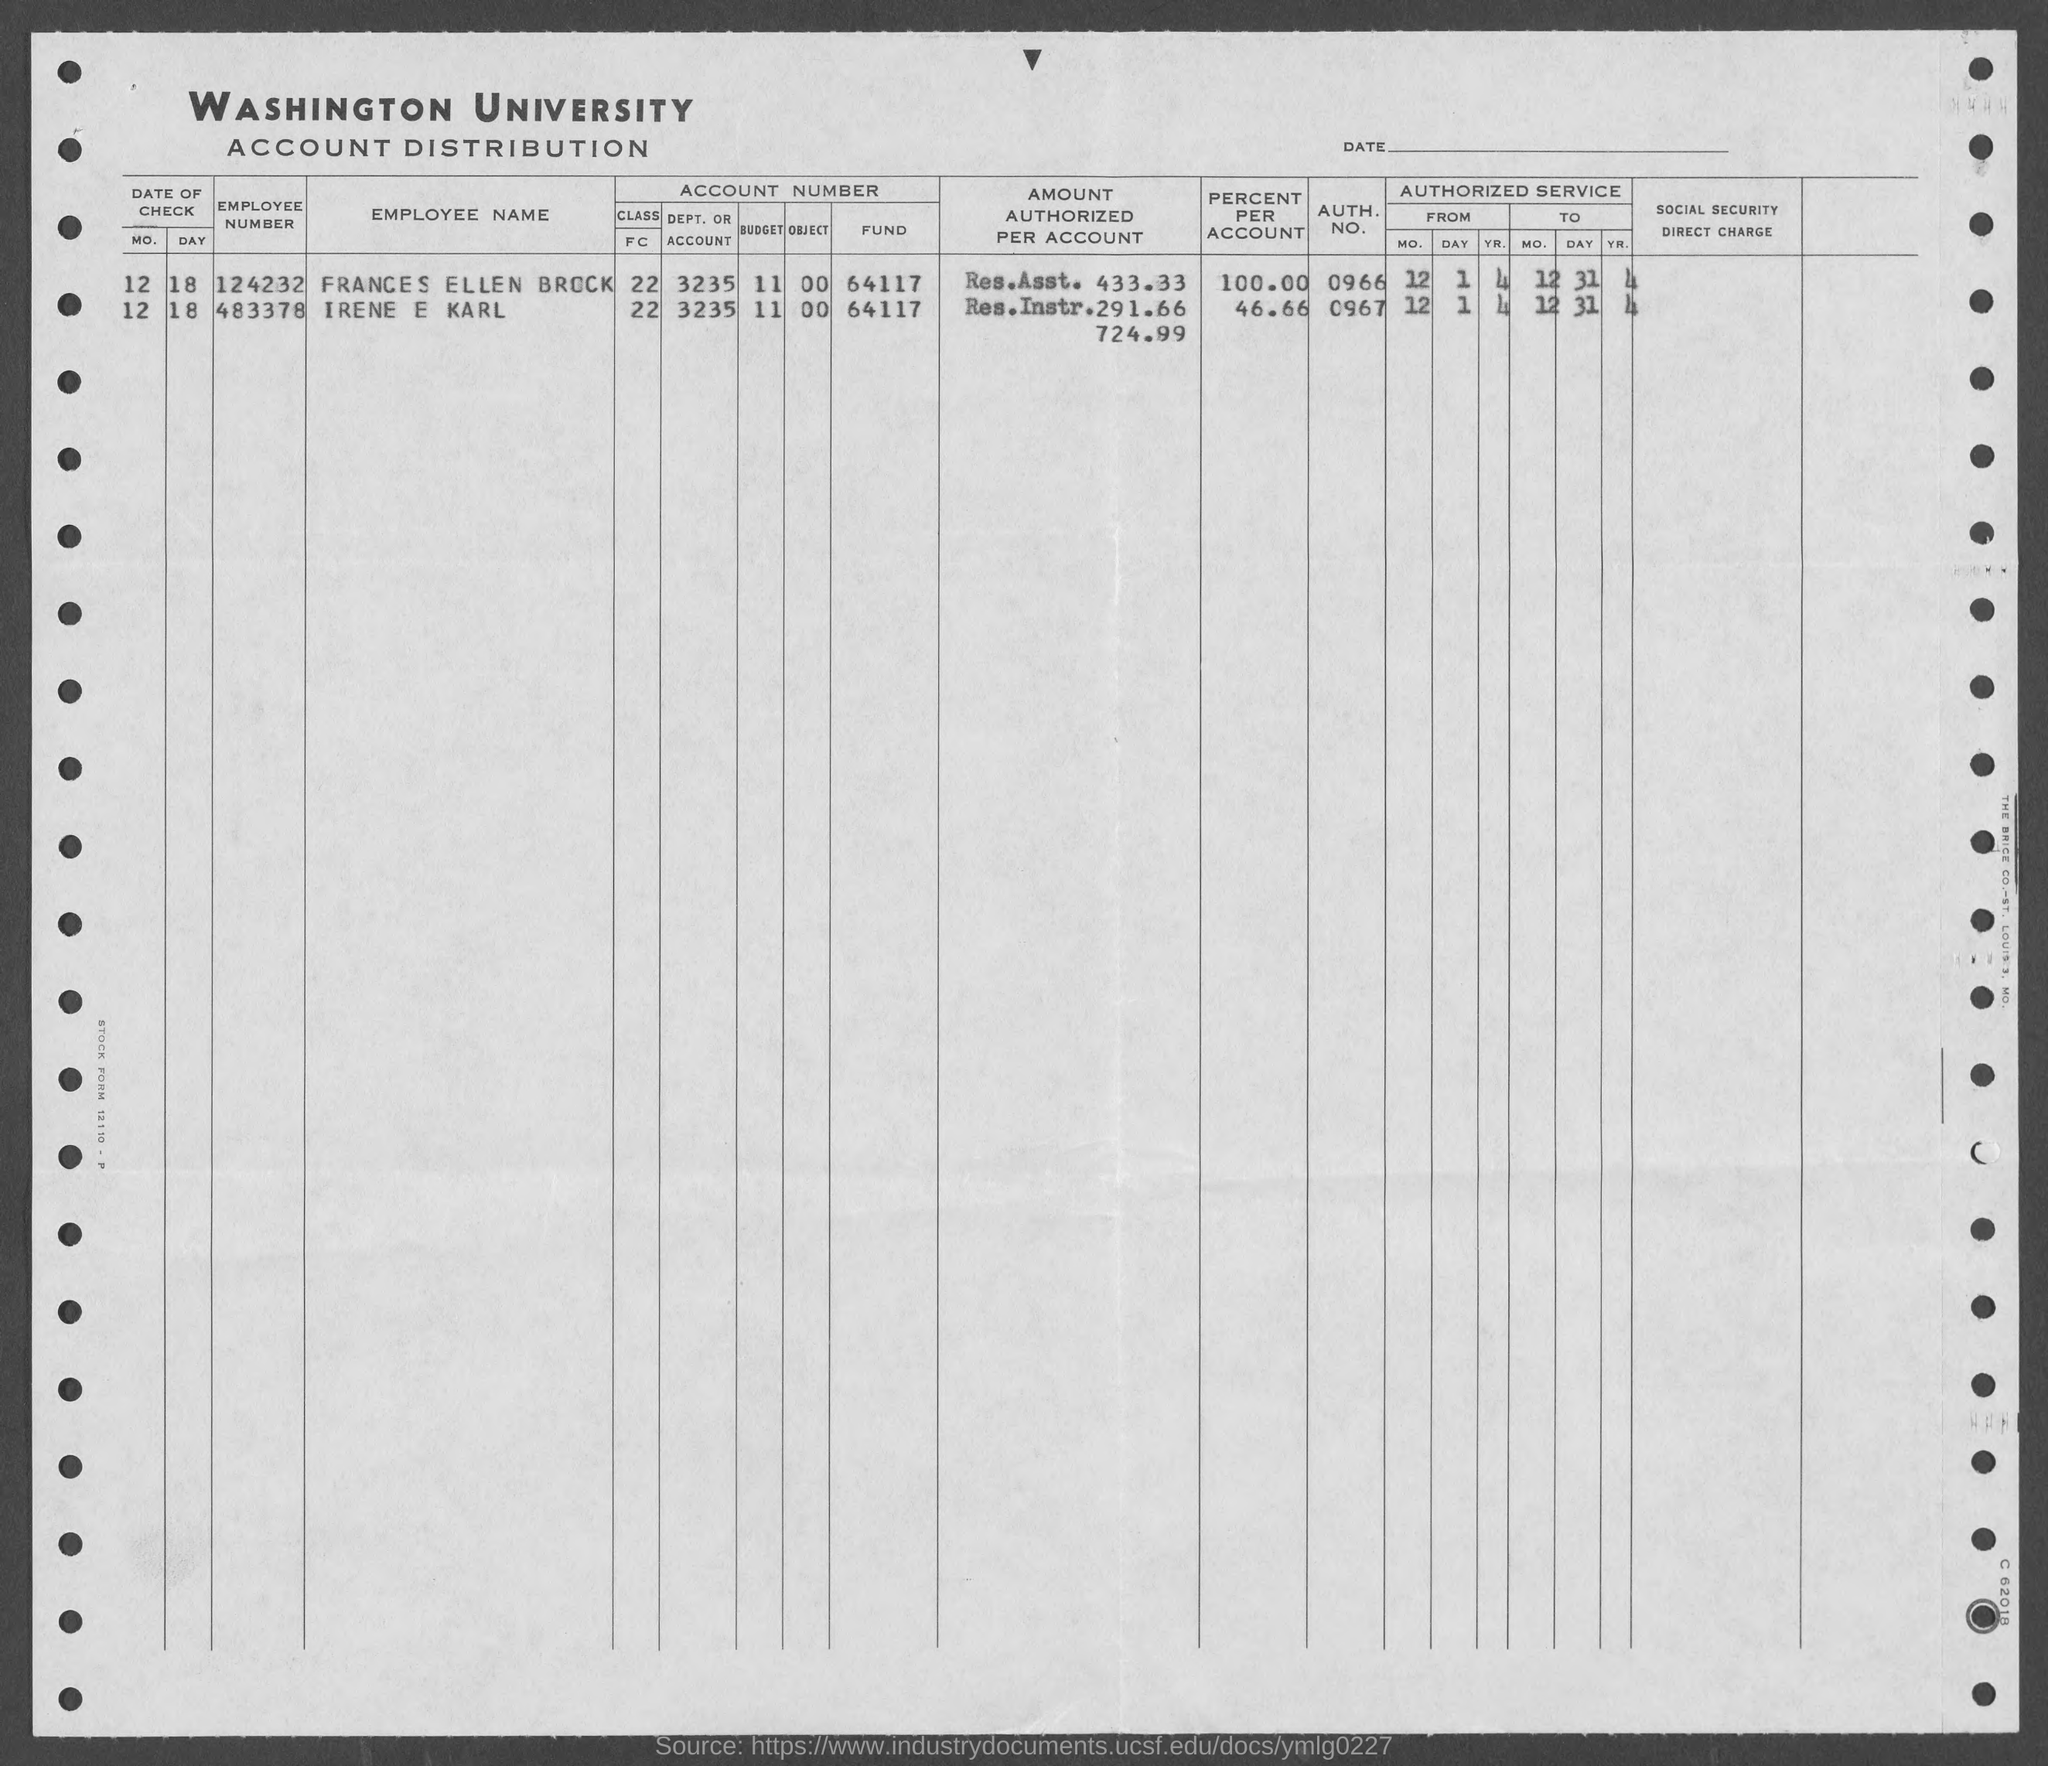What is the first title in the document?
Ensure brevity in your answer.  Washington University. What is the second title in the document?
Provide a succinct answer. Account Distribution. What is the employee number of Irene E Karl?
Make the answer very short. 483378. Who is employee number 124232?
Ensure brevity in your answer.  Frances Ellen Brock. 